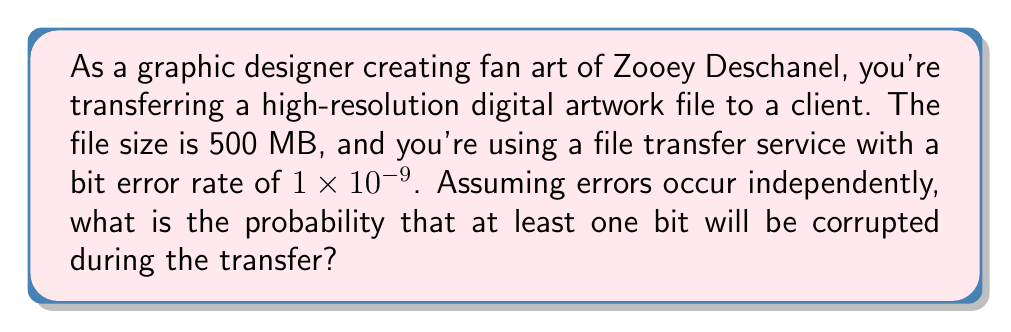Help me with this question. To solve this problem, we'll follow these steps:

1) First, let's calculate the number of bits in the file:
   500 MB = 500 * 8 * 1,000,000 bits = 4,000,000,000 bits

2) The probability of a single bit being corrupted is $1 \times 10^{-9}$

3) Therefore, the probability of a single bit not being corrupted is:
   $1 - (1 \times 10^{-9}) = 0.999999999$

4) For the entire file to be transferred without any corruption, all bits must be transferred correctly. The probability of this happening is:
   $$(0.999999999)^{4,000,000,000}$$

5) We can simplify this calculation using the exponential function:
   $$e^{4,000,000,000 \times \ln(0.999999999)}$$

6) Now, we want the probability of at least one bit being corrupted, which is the complement of all bits being transferred correctly:
   $$1 - e^{4,000,000,000 \times \ln(0.999999999)}$$

7) Using a calculator or computer:
   $$1 - e^{4,000,000,000 \times (-0.000000001)} = 1 - e^{-4} \approx 0.9817$$
Answer: The probability that at least one bit will be corrupted during the transfer is approximately 0.9817 or 98.17%. 